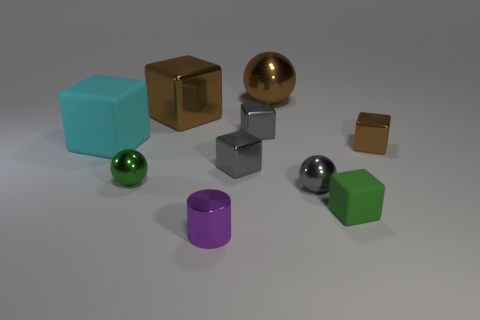There is a small metallic cube that is to the right of the tiny ball that is to the right of the green ball; is there a tiny green metallic ball right of it?
Keep it short and to the point. No. What is the block in front of the green metal sphere made of?
Make the answer very short. Rubber. There is a large cyan object; is its shape the same as the shiny thing that is in front of the gray shiny ball?
Your answer should be compact. No. Are there an equal number of cyan matte cubes that are in front of the large cyan thing and brown cubes to the left of the purple metal cylinder?
Ensure brevity in your answer.  No. What number of other things are made of the same material as the small brown cube?
Give a very brief answer. 7. How many metal things are small yellow cubes or small things?
Your response must be concise. 6. There is a brown shiny thing that is to the left of the purple shiny cylinder; does it have the same shape as the small brown metal object?
Offer a very short reply. Yes. Are there more cyan matte things that are behind the big brown ball than matte cubes?
Keep it short and to the point. No. How many blocks are left of the tiny green sphere and in front of the cyan matte cube?
Keep it short and to the point. 0. What color is the small metal ball to the right of the metallic sphere behind the big brown metal block?
Keep it short and to the point. Gray. 